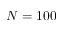<formula> <loc_0><loc_0><loc_500><loc_500>N = 1 0 0</formula> 